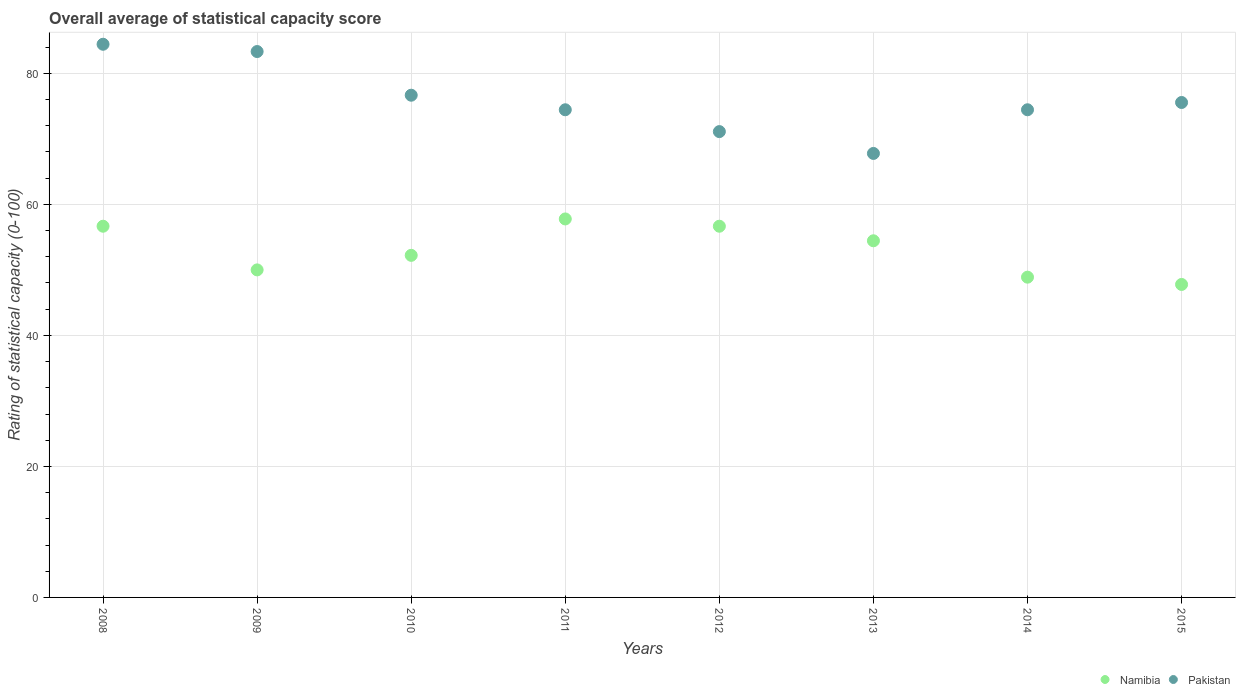Is the number of dotlines equal to the number of legend labels?
Your answer should be compact. Yes. What is the rating of statistical capacity in Namibia in 2010?
Give a very brief answer. 52.22. Across all years, what is the maximum rating of statistical capacity in Namibia?
Give a very brief answer. 57.78. Across all years, what is the minimum rating of statistical capacity in Namibia?
Your response must be concise. 47.78. What is the total rating of statistical capacity in Namibia in the graph?
Your response must be concise. 424.44. What is the difference between the rating of statistical capacity in Pakistan in 2011 and that in 2015?
Your answer should be very brief. -1.11. What is the difference between the rating of statistical capacity in Pakistan in 2013 and the rating of statistical capacity in Namibia in 2009?
Offer a terse response. 17.78. What is the average rating of statistical capacity in Pakistan per year?
Offer a very short reply. 75.97. In the year 2012, what is the difference between the rating of statistical capacity in Namibia and rating of statistical capacity in Pakistan?
Provide a succinct answer. -14.44. In how many years, is the rating of statistical capacity in Namibia greater than 16?
Offer a very short reply. 8. What is the ratio of the rating of statistical capacity in Namibia in 2012 to that in 2014?
Provide a succinct answer. 1.16. Is the rating of statistical capacity in Namibia in 2011 less than that in 2012?
Offer a very short reply. No. What is the difference between the highest and the second highest rating of statistical capacity in Namibia?
Your answer should be very brief. 1.11. What is the difference between the highest and the lowest rating of statistical capacity in Namibia?
Make the answer very short. 10. In how many years, is the rating of statistical capacity in Namibia greater than the average rating of statistical capacity in Namibia taken over all years?
Provide a short and direct response. 4. Does the rating of statistical capacity in Pakistan monotonically increase over the years?
Your answer should be very brief. No. Does the graph contain any zero values?
Provide a short and direct response. No. Where does the legend appear in the graph?
Give a very brief answer. Bottom right. What is the title of the graph?
Your response must be concise. Overall average of statistical capacity score. Does "Oman" appear as one of the legend labels in the graph?
Offer a very short reply. No. What is the label or title of the Y-axis?
Your answer should be compact. Rating of statistical capacity (0-100). What is the Rating of statistical capacity (0-100) in Namibia in 2008?
Your answer should be very brief. 56.67. What is the Rating of statistical capacity (0-100) in Pakistan in 2008?
Offer a very short reply. 84.44. What is the Rating of statistical capacity (0-100) of Namibia in 2009?
Your answer should be very brief. 50. What is the Rating of statistical capacity (0-100) of Pakistan in 2009?
Offer a terse response. 83.33. What is the Rating of statistical capacity (0-100) of Namibia in 2010?
Your answer should be very brief. 52.22. What is the Rating of statistical capacity (0-100) in Pakistan in 2010?
Your answer should be compact. 76.67. What is the Rating of statistical capacity (0-100) in Namibia in 2011?
Offer a very short reply. 57.78. What is the Rating of statistical capacity (0-100) in Pakistan in 2011?
Provide a short and direct response. 74.44. What is the Rating of statistical capacity (0-100) of Namibia in 2012?
Your answer should be compact. 56.67. What is the Rating of statistical capacity (0-100) in Pakistan in 2012?
Keep it short and to the point. 71.11. What is the Rating of statistical capacity (0-100) in Namibia in 2013?
Keep it short and to the point. 54.44. What is the Rating of statistical capacity (0-100) in Pakistan in 2013?
Your answer should be compact. 67.78. What is the Rating of statistical capacity (0-100) of Namibia in 2014?
Offer a very short reply. 48.89. What is the Rating of statistical capacity (0-100) of Pakistan in 2014?
Give a very brief answer. 74.44. What is the Rating of statistical capacity (0-100) in Namibia in 2015?
Your answer should be very brief. 47.78. What is the Rating of statistical capacity (0-100) in Pakistan in 2015?
Your answer should be very brief. 75.56. Across all years, what is the maximum Rating of statistical capacity (0-100) in Namibia?
Give a very brief answer. 57.78. Across all years, what is the maximum Rating of statistical capacity (0-100) of Pakistan?
Give a very brief answer. 84.44. Across all years, what is the minimum Rating of statistical capacity (0-100) of Namibia?
Make the answer very short. 47.78. Across all years, what is the minimum Rating of statistical capacity (0-100) of Pakistan?
Offer a terse response. 67.78. What is the total Rating of statistical capacity (0-100) of Namibia in the graph?
Give a very brief answer. 424.44. What is the total Rating of statistical capacity (0-100) of Pakistan in the graph?
Offer a very short reply. 607.78. What is the difference between the Rating of statistical capacity (0-100) of Pakistan in 2008 and that in 2009?
Give a very brief answer. 1.11. What is the difference between the Rating of statistical capacity (0-100) of Namibia in 2008 and that in 2010?
Your response must be concise. 4.44. What is the difference between the Rating of statistical capacity (0-100) of Pakistan in 2008 and that in 2010?
Ensure brevity in your answer.  7.78. What is the difference between the Rating of statistical capacity (0-100) in Namibia in 2008 and that in 2011?
Your answer should be compact. -1.11. What is the difference between the Rating of statistical capacity (0-100) in Pakistan in 2008 and that in 2011?
Your response must be concise. 10. What is the difference between the Rating of statistical capacity (0-100) in Namibia in 2008 and that in 2012?
Provide a short and direct response. 0. What is the difference between the Rating of statistical capacity (0-100) in Pakistan in 2008 and that in 2012?
Your answer should be compact. 13.33. What is the difference between the Rating of statistical capacity (0-100) of Namibia in 2008 and that in 2013?
Your response must be concise. 2.22. What is the difference between the Rating of statistical capacity (0-100) of Pakistan in 2008 and that in 2013?
Ensure brevity in your answer.  16.67. What is the difference between the Rating of statistical capacity (0-100) in Namibia in 2008 and that in 2014?
Offer a very short reply. 7.78. What is the difference between the Rating of statistical capacity (0-100) in Pakistan in 2008 and that in 2014?
Your answer should be compact. 10. What is the difference between the Rating of statistical capacity (0-100) of Namibia in 2008 and that in 2015?
Your response must be concise. 8.89. What is the difference between the Rating of statistical capacity (0-100) in Pakistan in 2008 and that in 2015?
Your answer should be compact. 8.89. What is the difference between the Rating of statistical capacity (0-100) in Namibia in 2009 and that in 2010?
Give a very brief answer. -2.22. What is the difference between the Rating of statistical capacity (0-100) in Pakistan in 2009 and that in 2010?
Provide a succinct answer. 6.67. What is the difference between the Rating of statistical capacity (0-100) in Namibia in 2009 and that in 2011?
Offer a terse response. -7.78. What is the difference between the Rating of statistical capacity (0-100) in Pakistan in 2009 and that in 2011?
Offer a very short reply. 8.89. What is the difference between the Rating of statistical capacity (0-100) of Namibia in 2009 and that in 2012?
Your answer should be very brief. -6.67. What is the difference between the Rating of statistical capacity (0-100) of Pakistan in 2009 and that in 2012?
Your response must be concise. 12.22. What is the difference between the Rating of statistical capacity (0-100) of Namibia in 2009 and that in 2013?
Your answer should be compact. -4.44. What is the difference between the Rating of statistical capacity (0-100) in Pakistan in 2009 and that in 2013?
Keep it short and to the point. 15.56. What is the difference between the Rating of statistical capacity (0-100) in Pakistan in 2009 and that in 2014?
Provide a succinct answer. 8.89. What is the difference between the Rating of statistical capacity (0-100) in Namibia in 2009 and that in 2015?
Provide a short and direct response. 2.22. What is the difference between the Rating of statistical capacity (0-100) in Pakistan in 2009 and that in 2015?
Your answer should be compact. 7.78. What is the difference between the Rating of statistical capacity (0-100) of Namibia in 2010 and that in 2011?
Your response must be concise. -5.56. What is the difference between the Rating of statistical capacity (0-100) in Pakistan in 2010 and that in 2011?
Your answer should be very brief. 2.22. What is the difference between the Rating of statistical capacity (0-100) of Namibia in 2010 and that in 2012?
Offer a very short reply. -4.44. What is the difference between the Rating of statistical capacity (0-100) of Pakistan in 2010 and that in 2012?
Your response must be concise. 5.56. What is the difference between the Rating of statistical capacity (0-100) of Namibia in 2010 and that in 2013?
Provide a succinct answer. -2.22. What is the difference between the Rating of statistical capacity (0-100) in Pakistan in 2010 and that in 2013?
Your response must be concise. 8.89. What is the difference between the Rating of statistical capacity (0-100) in Namibia in 2010 and that in 2014?
Keep it short and to the point. 3.33. What is the difference between the Rating of statistical capacity (0-100) in Pakistan in 2010 and that in 2014?
Your response must be concise. 2.22. What is the difference between the Rating of statistical capacity (0-100) of Namibia in 2010 and that in 2015?
Ensure brevity in your answer.  4.44. What is the difference between the Rating of statistical capacity (0-100) of Pakistan in 2010 and that in 2015?
Offer a terse response. 1.11. What is the difference between the Rating of statistical capacity (0-100) of Namibia in 2011 and that in 2012?
Give a very brief answer. 1.11. What is the difference between the Rating of statistical capacity (0-100) of Pakistan in 2011 and that in 2012?
Offer a terse response. 3.33. What is the difference between the Rating of statistical capacity (0-100) in Namibia in 2011 and that in 2013?
Ensure brevity in your answer.  3.33. What is the difference between the Rating of statistical capacity (0-100) in Pakistan in 2011 and that in 2013?
Offer a very short reply. 6.67. What is the difference between the Rating of statistical capacity (0-100) in Namibia in 2011 and that in 2014?
Your answer should be compact. 8.89. What is the difference between the Rating of statistical capacity (0-100) of Pakistan in 2011 and that in 2014?
Ensure brevity in your answer.  0. What is the difference between the Rating of statistical capacity (0-100) of Namibia in 2011 and that in 2015?
Your response must be concise. 10. What is the difference between the Rating of statistical capacity (0-100) of Pakistan in 2011 and that in 2015?
Your answer should be compact. -1.11. What is the difference between the Rating of statistical capacity (0-100) in Namibia in 2012 and that in 2013?
Your answer should be compact. 2.22. What is the difference between the Rating of statistical capacity (0-100) of Namibia in 2012 and that in 2014?
Make the answer very short. 7.78. What is the difference between the Rating of statistical capacity (0-100) in Pakistan in 2012 and that in 2014?
Give a very brief answer. -3.33. What is the difference between the Rating of statistical capacity (0-100) of Namibia in 2012 and that in 2015?
Keep it short and to the point. 8.89. What is the difference between the Rating of statistical capacity (0-100) in Pakistan in 2012 and that in 2015?
Your answer should be compact. -4.44. What is the difference between the Rating of statistical capacity (0-100) of Namibia in 2013 and that in 2014?
Make the answer very short. 5.56. What is the difference between the Rating of statistical capacity (0-100) of Pakistan in 2013 and that in 2014?
Your answer should be very brief. -6.67. What is the difference between the Rating of statistical capacity (0-100) in Namibia in 2013 and that in 2015?
Your response must be concise. 6.67. What is the difference between the Rating of statistical capacity (0-100) in Pakistan in 2013 and that in 2015?
Offer a terse response. -7.78. What is the difference between the Rating of statistical capacity (0-100) of Namibia in 2014 and that in 2015?
Your answer should be compact. 1.11. What is the difference between the Rating of statistical capacity (0-100) in Pakistan in 2014 and that in 2015?
Your response must be concise. -1.11. What is the difference between the Rating of statistical capacity (0-100) of Namibia in 2008 and the Rating of statistical capacity (0-100) of Pakistan in 2009?
Keep it short and to the point. -26.67. What is the difference between the Rating of statistical capacity (0-100) of Namibia in 2008 and the Rating of statistical capacity (0-100) of Pakistan in 2010?
Give a very brief answer. -20. What is the difference between the Rating of statistical capacity (0-100) in Namibia in 2008 and the Rating of statistical capacity (0-100) in Pakistan in 2011?
Your response must be concise. -17.78. What is the difference between the Rating of statistical capacity (0-100) of Namibia in 2008 and the Rating of statistical capacity (0-100) of Pakistan in 2012?
Keep it short and to the point. -14.44. What is the difference between the Rating of statistical capacity (0-100) in Namibia in 2008 and the Rating of statistical capacity (0-100) in Pakistan in 2013?
Make the answer very short. -11.11. What is the difference between the Rating of statistical capacity (0-100) in Namibia in 2008 and the Rating of statistical capacity (0-100) in Pakistan in 2014?
Your answer should be very brief. -17.78. What is the difference between the Rating of statistical capacity (0-100) in Namibia in 2008 and the Rating of statistical capacity (0-100) in Pakistan in 2015?
Keep it short and to the point. -18.89. What is the difference between the Rating of statistical capacity (0-100) in Namibia in 2009 and the Rating of statistical capacity (0-100) in Pakistan in 2010?
Provide a short and direct response. -26.67. What is the difference between the Rating of statistical capacity (0-100) in Namibia in 2009 and the Rating of statistical capacity (0-100) in Pakistan in 2011?
Your answer should be very brief. -24.44. What is the difference between the Rating of statistical capacity (0-100) of Namibia in 2009 and the Rating of statistical capacity (0-100) of Pakistan in 2012?
Ensure brevity in your answer.  -21.11. What is the difference between the Rating of statistical capacity (0-100) of Namibia in 2009 and the Rating of statistical capacity (0-100) of Pakistan in 2013?
Keep it short and to the point. -17.78. What is the difference between the Rating of statistical capacity (0-100) of Namibia in 2009 and the Rating of statistical capacity (0-100) of Pakistan in 2014?
Your answer should be compact. -24.44. What is the difference between the Rating of statistical capacity (0-100) in Namibia in 2009 and the Rating of statistical capacity (0-100) in Pakistan in 2015?
Your answer should be very brief. -25.56. What is the difference between the Rating of statistical capacity (0-100) in Namibia in 2010 and the Rating of statistical capacity (0-100) in Pakistan in 2011?
Ensure brevity in your answer.  -22.22. What is the difference between the Rating of statistical capacity (0-100) in Namibia in 2010 and the Rating of statistical capacity (0-100) in Pakistan in 2012?
Keep it short and to the point. -18.89. What is the difference between the Rating of statistical capacity (0-100) of Namibia in 2010 and the Rating of statistical capacity (0-100) of Pakistan in 2013?
Offer a terse response. -15.56. What is the difference between the Rating of statistical capacity (0-100) in Namibia in 2010 and the Rating of statistical capacity (0-100) in Pakistan in 2014?
Provide a succinct answer. -22.22. What is the difference between the Rating of statistical capacity (0-100) in Namibia in 2010 and the Rating of statistical capacity (0-100) in Pakistan in 2015?
Give a very brief answer. -23.33. What is the difference between the Rating of statistical capacity (0-100) of Namibia in 2011 and the Rating of statistical capacity (0-100) of Pakistan in 2012?
Offer a very short reply. -13.33. What is the difference between the Rating of statistical capacity (0-100) of Namibia in 2011 and the Rating of statistical capacity (0-100) of Pakistan in 2013?
Your response must be concise. -10. What is the difference between the Rating of statistical capacity (0-100) of Namibia in 2011 and the Rating of statistical capacity (0-100) of Pakistan in 2014?
Provide a succinct answer. -16.67. What is the difference between the Rating of statistical capacity (0-100) in Namibia in 2011 and the Rating of statistical capacity (0-100) in Pakistan in 2015?
Keep it short and to the point. -17.78. What is the difference between the Rating of statistical capacity (0-100) in Namibia in 2012 and the Rating of statistical capacity (0-100) in Pakistan in 2013?
Make the answer very short. -11.11. What is the difference between the Rating of statistical capacity (0-100) in Namibia in 2012 and the Rating of statistical capacity (0-100) in Pakistan in 2014?
Make the answer very short. -17.78. What is the difference between the Rating of statistical capacity (0-100) of Namibia in 2012 and the Rating of statistical capacity (0-100) of Pakistan in 2015?
Ensure brevity in your answer.  -18.89. What is the difference between the Rating of statistical capacity (0-100) in Namibia in 2013 and the Rating of statistical capacity (0-100) in Pakistan in 2014?
Offer a very short reply. -20. What is the difference between the Rating of statistical capacity (0-100) in Namibia in 2013 and the Rating of statistical capacity (0-100) in Pakistan in 2015?
Offer a terse response. -21.11. What is the difference between the Rating of statistical capacity (0-100) of Namibia in 2014 and the Rating of statistical capacity (0-100) of Pakistan in 2015?
Offer a very short reply. -26.67. What is the average Rating of statistical capacity (0-100) of Namibia per year?
Ensure brevity in your answer.  53.06. What is the average Rating of statistical capacity (0-100) of Pakistan per year?
Provide a short and direct response. 75.97. In the year 2008, what is the difference between the Rating of statistical capacity (0-100) of Namibia and Rating of statistical capacity (0-100) of Pakistan?
Offer a terse response. -27.78. In the year 2009, what is the difference between the Rating of statistical capacity (0-100) in Namibia and Rating of statistical capacity (0-100) in Pakistan?
Your answer should be very brief. -33.33. In the year 2010, what is the difference between the Rating of statistical capacity (0-100) in Namibia and Rating of statistical capacity (0-100) in Pakistan?
Provide a succinct answer. -24.44. In the year 2011, what is the difference between the Rating of statistical capacity (0-100) of Namibia and Rating of statistical capacity (0-100) of Pakistan?
Ensure brevity in your answer.  -16.67. In the year 2012, what is the difference between the Rating of statistical capacity (0-100) of Namibia and Rating of statistical capacity (0-100) of Pakistan?
Make the answer very short. -14.44. In the year 2013, what is the difference between the Rating of statistical capacity (0-100) in Namibia and Rating of statistical capacity (0-100) in Pakistan?
Your answer should be very brief. -13.33. In the year 2014, what is the difference between the Rating of statistical capacity (0-100) of Namibia and Rating of statistical capacity (0-100) of Pakistan?
Your answer should be very brief. -25.56. In the year 2015, what is the difference between the Rating of statistical capacity (0-100) in Namibia and Rating of statistical capacity (0-100) in Pakistan?
Make the answer very short. -27.78. What is the ratio of the Rating of statistical capacity (0-100) of Namibia in 2008 to that in 2009?
Give a very brief answer. 1.13. What is the ratio of the Rating of statistical capacity (0-100) in Pakistan in 2008 to that in 2009?
Offer a terse response. 1.01. What is the ratio of the Rating of statistical capacity (0-100) of Namibia in 2008 to that in 2010?
Offer a terse response. 1.09. What is the ratio of the Rating of statistical capacity (0-100) of Pakistan in 2008 to that in 2010?
Your answer should be compact. 1.1. What is the ratio of the Rating of statistical capacity (0-100) of Namibia in 2008 to that in 2011?
Your response must be concise. 0.98. What is the ratio of the Rating of statistical capacity (0-100) of Pakistan in 2008 to that in 2011?
Your response must be concise. 1.13. What is the ratio of the Rating of statistical capacity (0-100) in Pakistan in 2008 to that in 2012?
Make the answer very short. 1.19. What is the ratio of the Rating of statistical capacity (0-100) of Namibia in 2008 to that in 2013?
Your response must be concise. 1.04. What is the ratio of the Rating of statistical capacity (0-100) of Pakistan in 2008 to that in 2013?
Offer a terse response. 1.25. What is the ratio of the Rating of statistical capacity (0-100) of Namibia in 2008 to that in 2014?
Keep it short and to the point. 1.16. What is the ratio of the Rating of statistical capacity (0-100) in Pakistan in 2008 to that in 2014?
Your answer should be compact. 1.13. What is the ratio of the Rating of statistical capacity (0-100) in Namibia in 2008 to that in 2015?
Give a very brief answer. 1.19. What is the ratio of the Rating of statistical capacity (0-100) in Pakistan in 2008 to that in 2015?
Provide a succinct answer. 1.12. What is the ratio of the Rating of statistical capacity (0-100) in Namibia in 2009 to that in 2010?
Give a very brief answer. 0.96. What is the ratio of the Rating of statistical capacity (0-100) of Pakistan in 2009 to that in 2010?
Provide a short and direct response. 1.09. What is the ratio of the Rating of statistical capacity (0-100) of Namibia in 2009 to that in 2011?
Make the answer very short. 0.87. What is the ratio of the Rating of statistical capacity (0-100) in Pakistan in 2009 to that in 2011?
Give a very brief answer. 1.12. What is the ratio of the Rating of statistical capacity (0-100) in Namibia in 2009 to that in 2012?
Give a very brief answer. 0.88. What is the ratio of the Rating of statistical capacity (0-100) of Pakistan in 2009 to that in 2012?
Ensure brevity in your answer.  1.17. What is the ratio of the Rating of statistical capacity (0-100) in Namibia in 2009 to that in 2013?
Offer a terse response. 0.92. What is the ratio of the Rating of statistical capacity (0-100) in Pakistan in 2009 to that in 2013?
Your answer should be very brief. 1.23. What is the ratio of the Rating of statistical capacity (0-100) of Namibia in 2009 to that in 2014?
Provide a succinct answer. 1.02. What is the ratio of the Rating of statistical capacity (0-100) in Pakistan in 2009 to that in 2014?
Provide a short and direct response. 1.12. What is the ratio of the Rating of statistical capacity (0-100) in Namibia in 2009 to that in 2015?
Provide a short and direct response. 1.05. What is the ratio of the Rating of statistical capacity (0-100) of Pakistan in 2009 to that in 2015?
Keep it short and to the point. 1.1. What is the ratio of the Rating of statistical capacity (0-100) of Namibia in 2010 to that in 2011?
Provide a short and direct response. 0.9. What is the ratio of the Rating of statistical capacity (0-100) in Pakistan in 2010 to that in 2011?
Keep it short and to the point. 1.03. What is the ratio of the Rating of statistical capacity (0-100) in Namibia in 2010 to that in 2012?
Keep it short and to the point. 0.92. What is the ratio of the Rating of statistical capacity (0-100) in Pakistan in 2010 to that in 2012?
Make the answer very short. 1.08. What is the ratio of the Rating of statistical capacity (0-100) in Namibia in 2010 to that in 2013?
Your answer should be compact. 0.96. What is the ratio of the Rating of statistical capacity (0-100) of Pakistan in 2010 to that in 2013?
Offer a very short reply. 1.13. What is the ratio of the Rating of statistical capacity (0-100) of Namibia in 2010 to that in 2014?
Your answer should be very brief. 1.07. What is the ratio of the Rating of statistical capacity (0-100) of Pakistan in 2010 to that in 2014?
Keep it short and to the point. 1.03. What is the ratio of the Rating of statistical capacity (0-100) of Namibia in 2010 to that in 2015?
Provide a succinct answer. 1.09. What is the ratio of the Rating of statistical capacity (0-100) in Pakistan in 2010 to that in 2015?
Make the answer very short. 1.01. What is the ratio of the Rating of statistical capacity (0-100) of Namibia in 2011 to that in 2012?
Your answer should be very brief. 1.02. What is the ratio of the Rating of statistical capacity (0-100) of Pakistan in 2011 to that in 2012?
Offer a very short reply. 1.05. What is the ratio of the Rating of statistical capacity (0-100) of Namibia in 2011 to that in 2013?
Provide a succinct answer. 1.06. What is the ratio of the Rating of statistical capacity (0-100) of Pakistan in 2011 to that in 2013?
Keep it short and to the point. 1.1. What is the ratio of the Rating of statistical capacity (0-100) in Namibia in 2011 to that in 2014?
Provide a short and direct response. 1.18. What is the ratio of the Rating of statistical capacity (0-100) of Pakistan in 2011 to that in 2014?
Keep it short and to the point. 1. What is the ratio of the Rating of statistical capacity (0-100) of Namibia in 2011 to that in 2015?
Provide a succinct answer. 1.21. What is the ratio of the Rating of statistical capacity (0-100) of Pakistan in 2011 to that in 2015?
Ensure brevity in your answer.  0.99. What is the ratio of the Rating of statistical capacity (0-100) of Namibia in 2012 to that in 2013?
Your response must be concise. 1.04. What is the ratio of the Rating of statistical capacity (0-100) of Pakistan in 2012 to that in 2013?
Ensure brevity in your answer.  1.05. What is the ratio of the Rating of statistical capacity (0-100) of Namibia in 2012 to that in 2014?
Ensure brevity in your answer.  1.16. What is the ratio of the Rating of statistical capacity (0-100) in Pakistan in 2012 to that in 2014?
Provide a short and direct response. 0.96. What is the ratio of the Rating of statistical capacity (0-100) of Namibia in 2012 to that in 2015?
Keep it short and to the point. 1.19. What is the ratio of the Rating of statistical capacity (0-100) in Namibia in 2013 to that in 2014?
Your answer should be very brief. 1.11. What is the ratio of the Rating of statistical capacity (0-100) of Pakistan in 2013 to that in 2014?
Make the answer very short. 0.91. What is the ratio of the Rating of statistical capacity (0-100) of Namibia in 2013 to that in 2015?
Your response must be concise. 1.14. What is the ratio of the Rating of statistical capacity (0-100) in Pakistan in 2013 to that in 2015?
Your answer should be compact. 0.9. What is the ratio of the Rating of statistical capacity (0-100) in Namibia in 2014 to that in 2015?
Keep it short and to the point. 1.02. What is the difference between the highest and the second highest Rating of statistical capacity (0-100) of Pakistan?
Provide a succinct answer. 1.11. What is the difference between the highest and the lowest Rating of statistical capacity (0-100) in Namibia?
Provide a short and direct response. 10. What is the difference between the highest and the lowest Rating of statistical capacity (0-100) in Pakistan?
Keep it short and to the point. 16.67. 